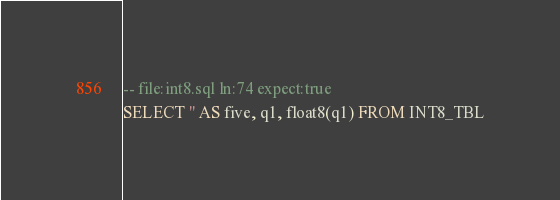<code> <loc_0><loc_0><loc_500><loc_500><_SQL_>-- file:int8.sql ln:74 expect:true
SELECT '' AS five, q1, float8(q1) FROM INT8_TBL
</code> 